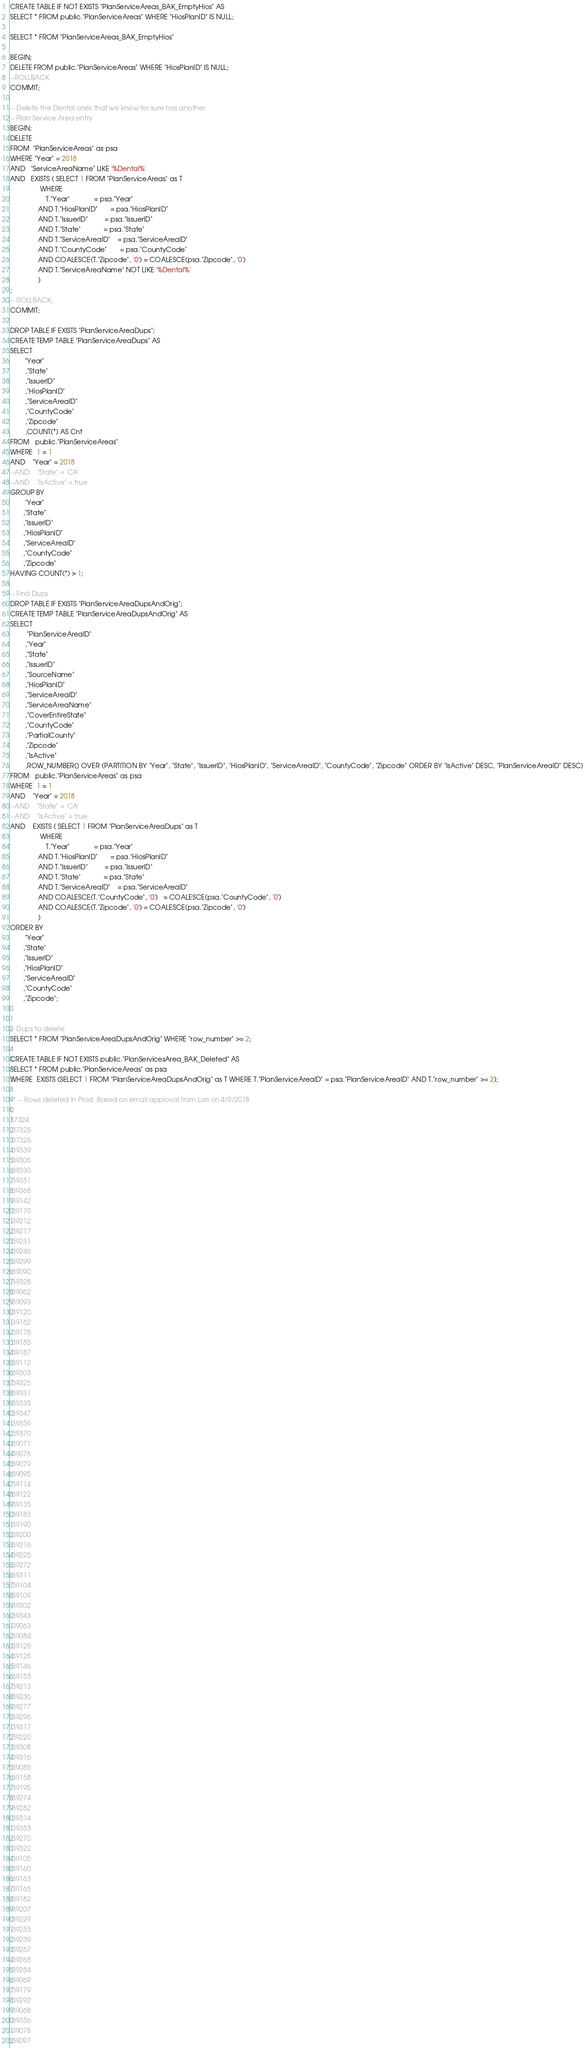<code> <loc_0><loc_0><loc_500><loc_500><_SQL_>CREATE TABLE IF NOT EXISTS "PlanServiceAreas_BAK_EmptyHios" AS 
SELECT * FROM public."PlanServiceAreas" WHERE "HiosPlanID" IS NULL;

SELECT * FROM "PlanServiceAreas_BAK_EmptyHios"

BEGIN;
DELETE FROM public."PlanServiceAreas" WHERE "HiosPlanID" IS NULL;
--ROLLBACK
COMMIT;

-- Delete the Dental ones that we know for sure has another
-- Plan Service Area entry
BEGIN;
DELETE 
FROM  "PlanServiceAreas" as psa
WHERE "Year" = 2018 
AND   "ServiceAreaName" LIKE '%Dental%'
AND   EXISTS ( SELECT 1 FROM "PlanServiceAreas" as T 
                WHERE 
                   T."Year"             = psa."Year"
               AND T."HiosPlanID"       = psa."HiosPlanID"
               AND T."IssuerID"         = psa."IssuerID"
               AND T."State"            = psa."State"
               AND T."ServiceAreaID"    = psa."ServiceAreaID"
               AND T."CountyCode"       = psa."CountyCode"
               AND COALESCE(T."Zipcode", '0') = COALESCE(psa."Zipcode", '0')
               AND T."ServiceAreaName" NOT LIKE '%Dental%'
               )
;
-- ROLLBACK;               
COMMIT;

DROP TABLE IF EXISTS "PlanServiceAreaDups";
CREATE TEMP TABLE "PlanServiceAreaDups" AS 
SELECT 
        "Year"
        ,"State"
        ,"IssuerID"
        ,"HiosPlanID"
        ,"ServiceAreaID"
        ,"CountyCode"
        ,"Zipcode"
        ,COUNT(*) AS Cnt
FROM   public."PlanServiceAreas"
WHERE  1 = 1
AND    "Year" = 2018
--AND    "State" = 'CA'
--AND    "IsActive" = true
GROUP BY
        "Year"
       ,"State"
       ,"IssuerID"
       ,"HiosPlanID"
       ,"ServiceAreaID"
       ,"CountyCode"
       ,"Zipcode"
HAVING COUNT(*) > 1;

-- Find Dups
DROP TABLE IF EXISTS "PlanServiceAreaDupsAndOrig";
CREATE TEMP TABLE "PlanServiceAreaDupsAndOrig" AS 
SELECT 
         "PlanServiceAreaID"
        ,"Year"
        ,"State"
        ,"IssuerID"
        ,"SourceName"
        ,"HiosPlanID"
        ,"ServiceAreaID"
        ,"ServiceAreaName"
        ,"CoverEntireState"
        ,"CountyCode"
        ,"PartialCounty"
        ,"Zipcode"
        ,"IsActive"
        ,ROW_NUMBER() OVER (PARTITION BY "Year", "State", "IssuerID", "HiosPlanID", "ServiceAreaID", "CountyCode", "Zipcode" ORDER BY "IsActive" DESC, "PlanServiceAreaID" DESC)
FROM   public."PlanServiceAreas" as psa
WHERE  1 = 1
AND    "Year" = 2018
--AND    "State" = 'CA'
--AND    "IsActive" = true
AND    EXISTS ( SELECT 1 FROM "PlanServiceAreaDups" as T 
                WHERE 
                   T."Year"             = psa."Year"
               AND T."HiosPlanID"       = psa."HiosPlanID"
               AND T."IssuerID"         = psa."IssuerID"
               AND T."State"            = psa."State"
               AND T."ServiceAreaID"    = psa."ServiceAreaID"
               AND COALESCE(T."CountyCode", '0')   = COALESCE(psa."CountyCode", '0')
               AND COALESCE(T."Zipcode", '0') = COALESCE(psa."Zipcode", '0')
               )
ORDER BY
        "Year"
       ,"State"
       ,"IssuerID"
       ,"HiosPlanID"
       ,"ServiceAreaID"
       ,"CountyCode"
       ,"Zipcode";


-- Dups to delete
SELECT * FROM "PlanServiceAreaDupsAndOrig" WHERE "row_number" >= 2;

CREATE TABLE IF NOT EXISTS public."PlanServicesArea_BAK_Deleted" AS 
SELECT * FROM public."PlanServiceAreas" as psa
WHERE  EXISTS (SELECT 1 FROM "PlanServiceAreaDupsAndOrig" as T WHERE T."PlanServiceAreaID" = psa."PlanServiceAreaID" AND T."row_number" >= 2); 

/* -- Rows deleted in Prod. Based on email approval from Lori on 4/9/2018
(
37324
,37325
,37326
,39339
,39305
,39330
,39351
,39368
,39142
,39170
,39212
,39217
,39231
,39246
,39299
,39090
,39328
,39062
,39093
,39120
,39162
,39178
,39185
,39187
,39112
,39303
,39325
,39331
,39335
,39347
,39359
,39370
,39071
,39076
,39079
,39095
,39114
,39122
,39135
,39183
,39190
,39200
,39216
,39225
,39272
,39311
,39104
,39109
,39302
,39343
,39063
,39084
,39125
,39128
,39146
,39153
,39213
,39236
,39277
,39296
,39317
,39220
,39308
,39316
,39085
,39158
,39195
,39274
,39282
,39314
,39353
,39270
,39322
,39105
,39160
,39163
,39165
,39182
,39207
,39229
,39233
,39239
,39257
,39268
,39284
,39069
,39179
,39292
,39068
,39356
,39078
,39097</code> 